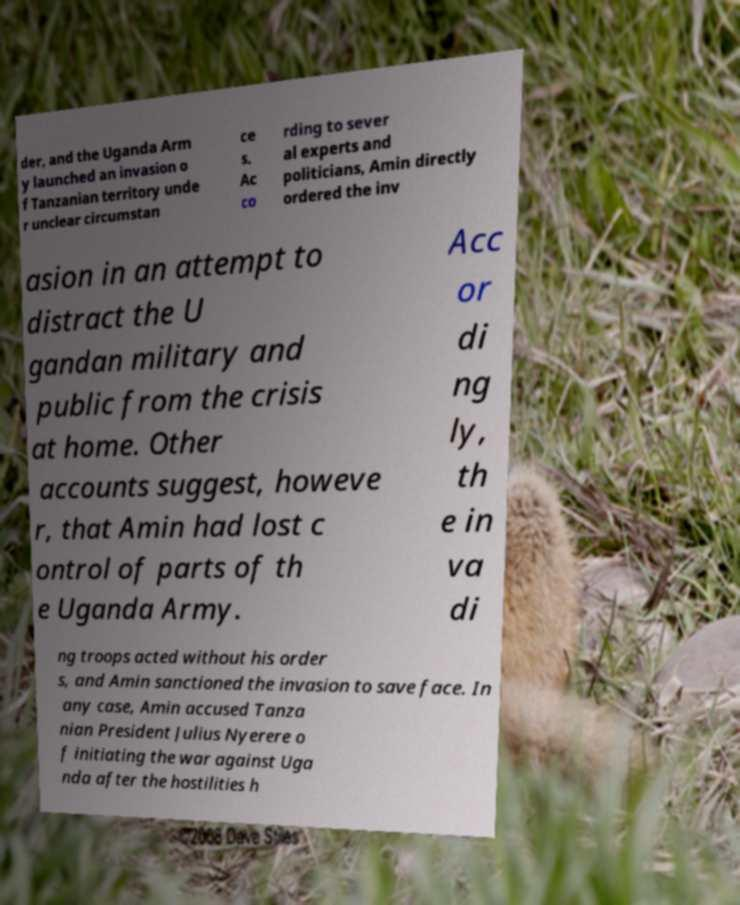Please read and relay the text visible in this image. What does it say? der, and the Uganda Arm y launched an invasion o f Tanzanian territory unde r unclear circumstan ce s. Ac co rding to sever al experts and politicians, Amin directly ordered the inv asion in an attempt to distract the U gandan military and public from the crisis at home. Other accounts suggest, howeve r, that Amin had lost c ontrol of parts of th e Uganda Army. Acc or di ng ly, th e in va di ng troops acted without his order s, and Amin sanctioned the invasion to save face. In any case, Amin accused Tanza nian President Julius Nyerere o f initiating the war against Uga nda after the hostilities h 